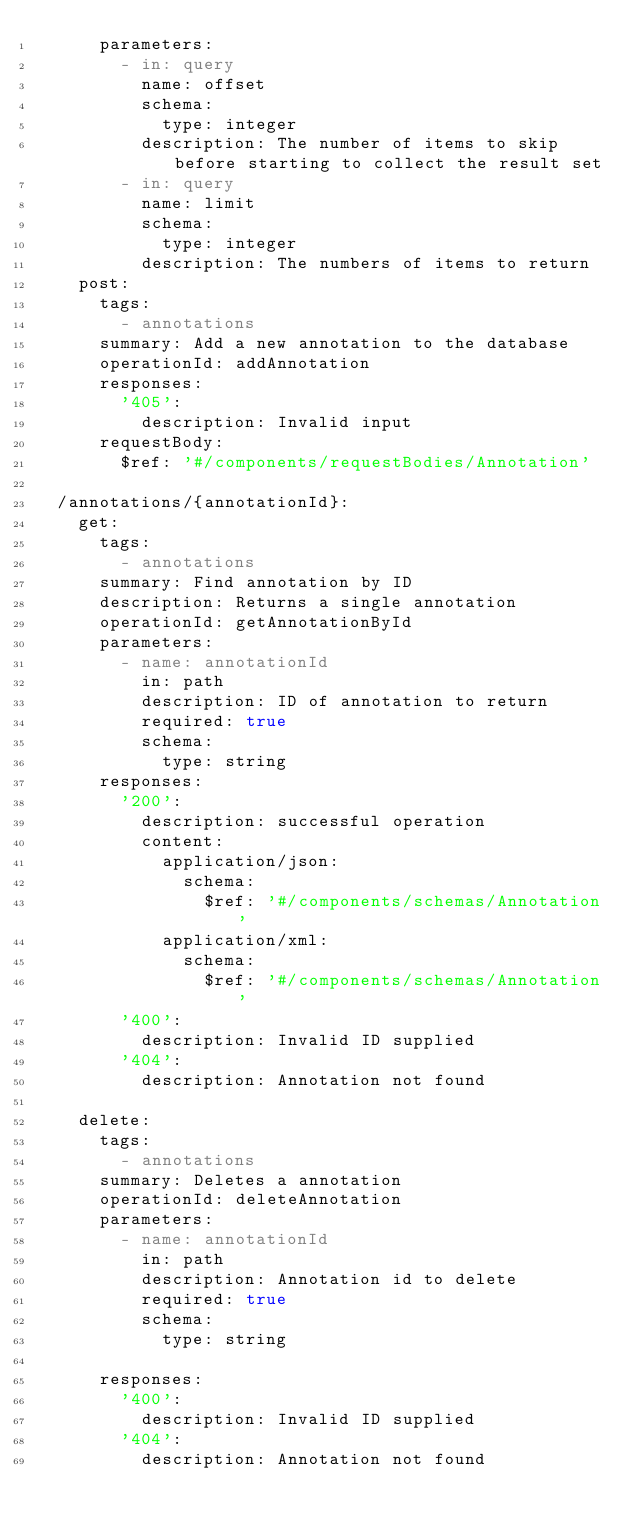Convert code to text. <code><loc_0><loc_0><loc_500><loc_500><_YAML_>      parameters:
        - in: query
          name: offset
          schema:
            type: integer
          description: The number of items to skip before starting to collect the result set
        - in: query
          name: limit
          schema:
            type: integer
          description: The numbers of items to return
    post:
      tags:
        - annotations
      summary: Add a new annotation to the database
      operationId: addAnnotation
      responses:
        '405':
          description: Invalid input
      requestBody:
        $ref: '#/components/requestBodies/Annotation'
    
  /annotations/{annotationId}:
    get:
      tags:
        - annotations
      summary: Find annotation by ID
      description: Returns a single annotation
      operationId: getAnnotationById
      parameters:
        - name: annotationId
          in: path
          description: ID of annotation to return
          required: true
          schema:
            type: string
      responses:
        '200':
          description: successful operation
          content:
            application/json:
              schema:
                $ref: '#/components/schemas/Annotation'
            application/xml:
              schema:
                $ref: '#/components/schemas/Annotation'
        '400':
          description: Invalid ID supplied
        '404':
          description: Annotation not found

    delete:
      tags:
        - annotations
      summary: Deletes a annotation
      operationId: deleteAnnotation
      parameters:
        - name: annotationId
          in: path
          description: Annotation id to delete
          required: true
          schema:
            type: string

      responses:
        '400':
          description: Invalid ID supplied
        '404':
          description: Annotation not found
</code> 